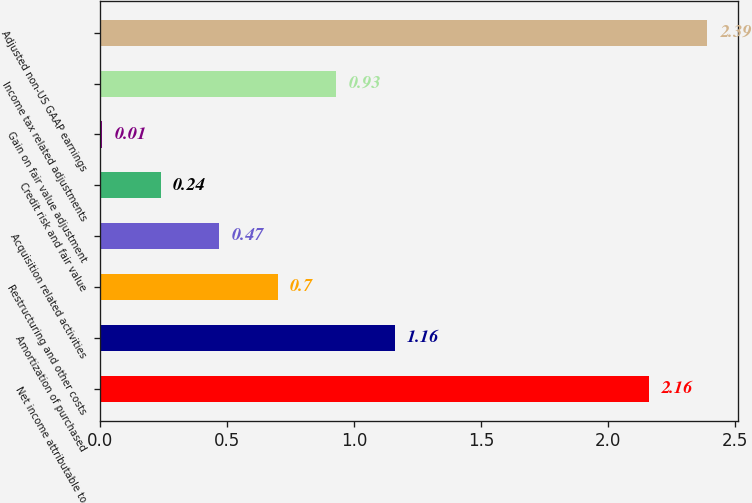<chart> <loc_0><loc_0><loc_500><loc_500><bar_chart><fcel>Net income attributable to<fcel>Amortization of purchased<fcel>Restructuring and other costs<fcel>Acquisition related activities<fcel>Credit risk and fair value<fcel>Gain on fair value adjustment<fcel>Income tax related adjustments<fcel>Adjusted non-US GAAP earnings<nl><fcel>2.16<fcel>1.16<fcel>0.7<fcel>0.47<fcel>0.24<fcel>0.01<fcel>0.93<fcel>2.39<nl></chart> 